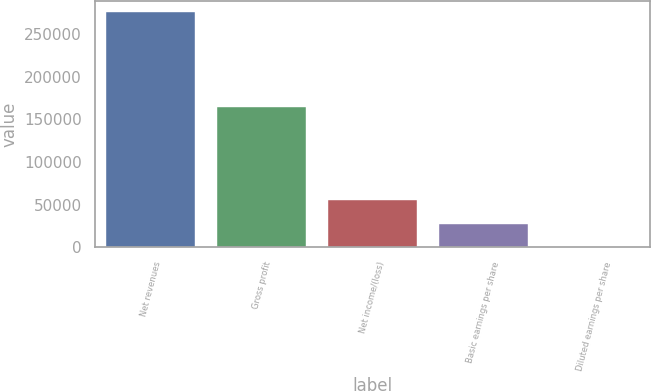Convert chart to OTSL. <chart><loc_0><loc_0><loc_500><loc_500><bar_chart><fcel>Net revenues<fcel>Gross profit<fcel>Net income/(loss)<fcel>Basic earnings per share<fcel>Diluted earnings per share<nl><fcel>275134<fcel>164205<fcel>55027.3<fcel>27513.9<fcel>0.6<nl></chart> 